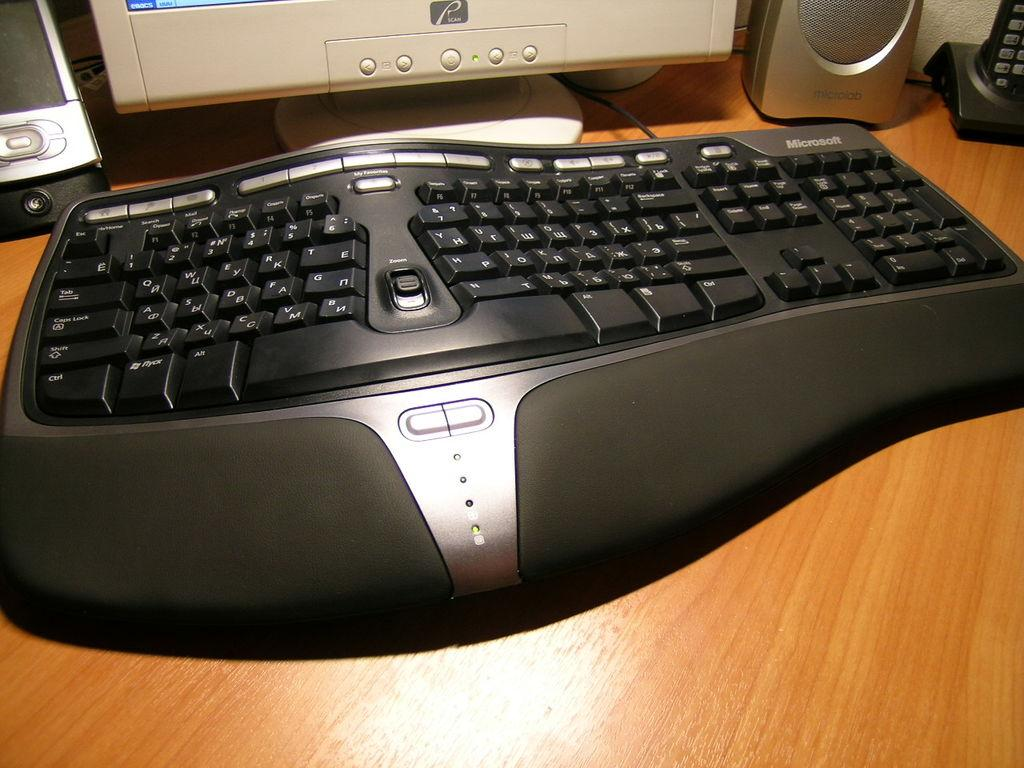<image>
Give a short and clear explanation of the subsequent image. QWERTY standard keys are shown on this Microsoft keyboard. 